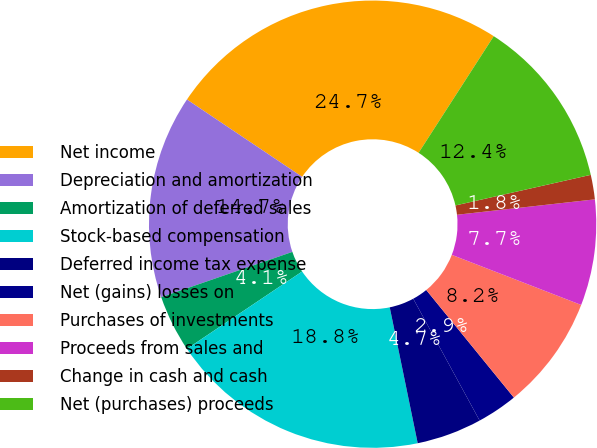Convert chart to OTSL. <chart><loc_0><loc_0><loc_500><loc_500><pie_chart><fcel>Net income<fcel>Depreciation and amortization<fcel>Amortization of deferred sales<fcel>Stock-based compensation<fcel>Deferred income tax expense<fcel>Net (gains) losses on<fcel>Purchases of investments<fcel>Proceeds from sales and<fcel>Change in cash and cash<fcel>Net (purchases) proceeds<nl><fcel>24.7%<fcel>14.7%<fcel>4.12%<fcel>18.82%<fcel>4.71%<fcel>2.94%<fcel>8.24%<fcel>7.65%<fcel>1.77%<fcel>12.35%<nl></chart> 